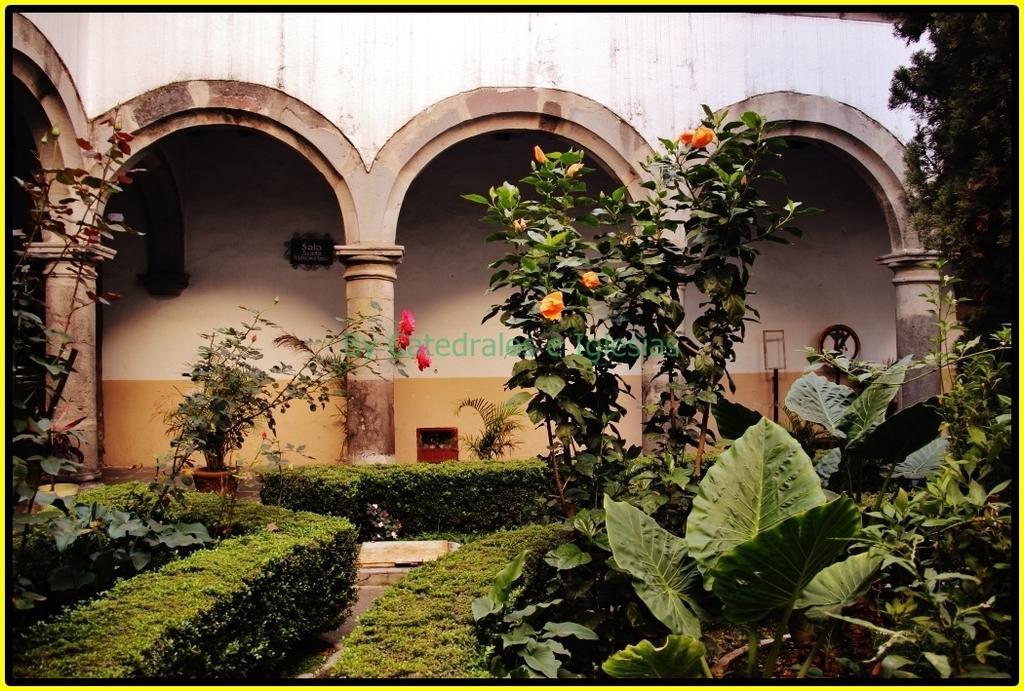Describe this image in one or two sentences. In this image in front there are plants and flowers. In the background of the image there is a wall. There are pillars and there are some objects. 